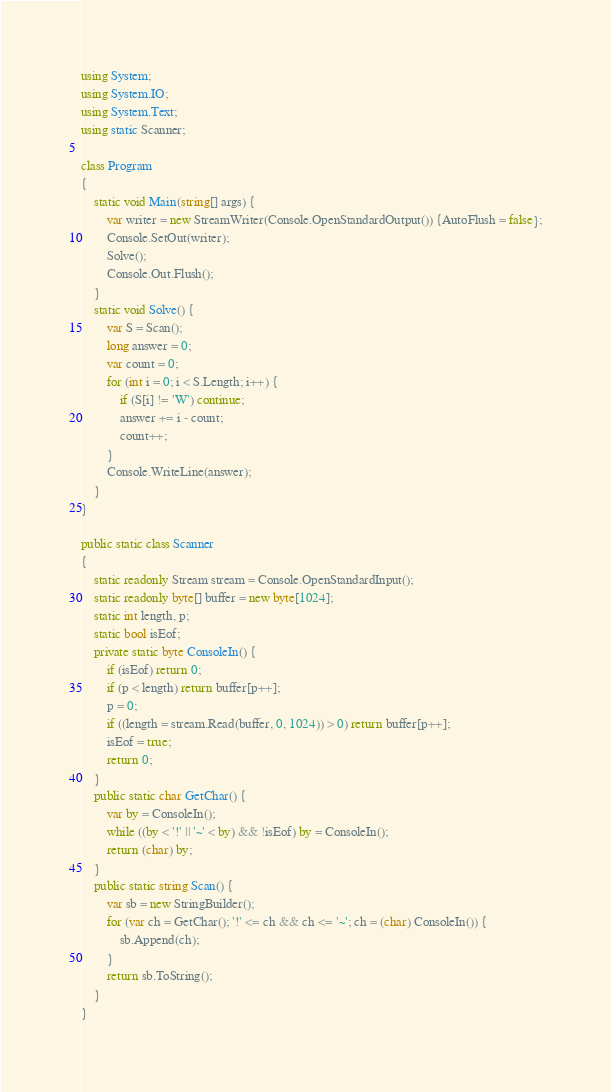<code> <loc_0><loc_0><loc_500><loc_500><_C#_>using System;
using System.IO;
using System.Text;
using static Scanner;

class Program
{
    static void Main(string[] args) {
        var writer = new StreamWriter(Console.OpenStandardOutput()) {AutoFlush = false};
        Console.SetOut(writer);
        Solve();
        Console.Out.Flush();
    }
    static void Solve() {
        var S = Scan();
        long answer = 0;
        var count = 0;
        for (int i = 0; i < S.Length; i++) {
            if (S[i] != 'W') continue;
            answer += i - count;
            count++;
        }
        Console.WriteLine(answer);
    }
}

public static class Scanner
{
    static readonly Stream stream = Console.OpenStandardInput();
    static readonly byte[] buffer = new byte[1024];
    static int length, p;
    static bool isEof;
    private static byte ConsoleIn() {
        if (isEof) return 0;
        if (p < length) return buffer[p++];
        p = 0;
        if ((length = stream.Read(buffer, 0, 1024)) > 0) return buffer[p++];
        isEof = true;
        return 0;
    }
    public static char GetChar() {
        var by = ConsoleIn();
        while ((by < '!' || '~' < by) && !isEof) by = ConsoleIn();
        return (char) by;
    }
    public static string Scan() {
        var sb = new StringBuilder();
        for (var ch = GetChar(); '!' <= ch && ch <= '~'; ch = (char) ConsoleIn()) {
            sb.Append(ch);
        }
        return sb.ToString();
    }
}</code> 